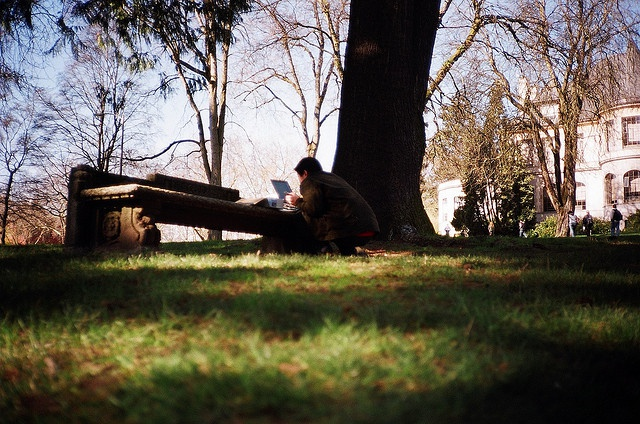Describe the objects in this image and their specific colors. I can see bench in black, maroon, and gray tones, people in black, maroon, white, and brown tones, laptop in black, gray, lightgray, darkblue, and darkgray tones, people in black, gray, navy, and maroon tones, and people in black, gray, and lightgray tones in this image. 